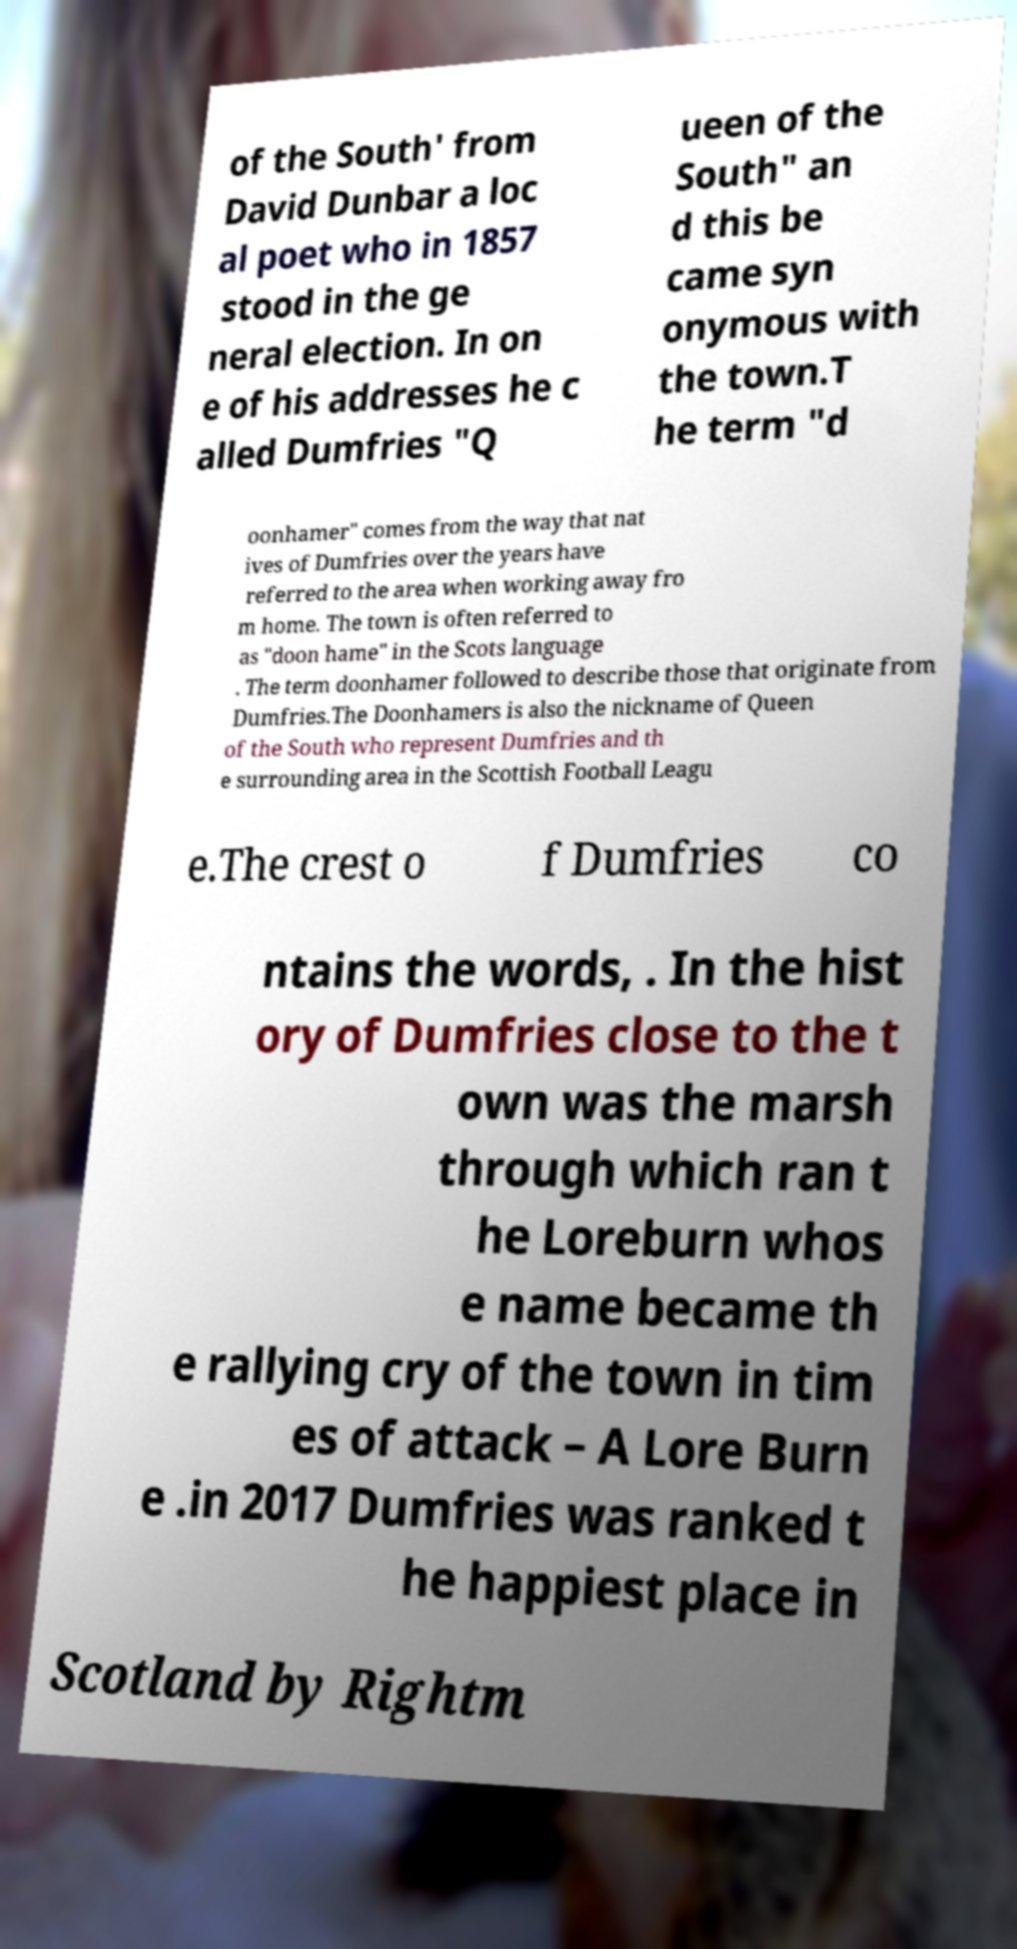For documentation purposes, I need the text within this image transcribed. Could you provide that? of the South' from David Dunbar a loc al poet who in 1857 stood in the ge neral election. In on e of his addresses he c alled Dumfries "Q ueen of the South" an d this be came syn onymous with the town.T he term "d oonhamer" comes from the way that nat ives of Dumfries over the years have referred to the area when working away fro m home. The town is often referred to as "doon hame" in the Scots language . The term doonhamer followed to describe those that originate from Dumfries.The Doonhamers is also the nickname of Queen of the South who represent Dumfries and th e surrounding area in the Scottish Football Leagu e.The crest o f Dumfries co ntains the words, . In the hist ory of Dumfries close to the t own was the marsh through which ran t he Loreburn whos e name became th e rallying cry of the town in tim es of attack – A Lore Burn e .in 2017 Dumfries was ranked t he happiest place in Scotland by Rightm 